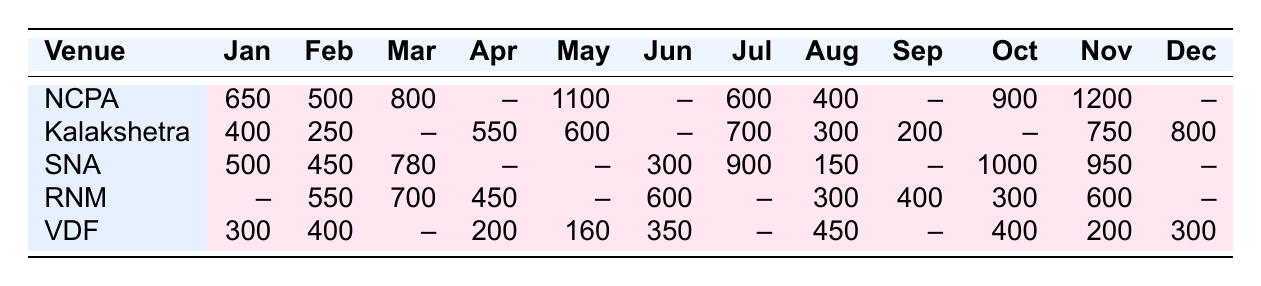What was the highest attendance recorded at the National Centre for the Performing Arts in 2023? The table shows that the highest attendance for the National Centre for the Performing Arts was in November, with a record of 1200.
Answer: 1200 Which month had the lowest attendance at the Kalakshetra Foundation? Referring to the attendance records, the lowest attendance at the Kalakshetra Foundation was in February, with 250.
Answer: 250 What is the total attendance at the Sangeet Natak Akademi for the months where records are available? By adding the recorded attendance: 500 (Jan) + 450 (Feb) + 780 (Mar) + 300 (Jun) + 900 (Jul) + 150 (Aug) + 1000 (Oct) + 950 (Nov) = 4230.
Answer: 4230 Did the Vijaywada Dance Festival show an increase in attendance from April to August? The attendance in April was 200, and in August it was 450. Since 450 is greater than 200, there was an increase in attendance from April to August.
Answer: Yes What was the average monthly attendance at the Ravindra Natya Mandir based on the available data? The recorded attendances are 550 (Feb), 700 (Mar), 450 (Apr), 600 (Jun), 300 (Aug), 400 (Sep), 300 (Oct), 600 (Nov). The total is 3000 and there are 8 months with data, giving an average of 3000/8 = 375.
Answer: 375 Which venue had a capacity closest to the average attendance recorded in the first half of 2023 across all venues? The average attendance in the first half is (650 + 500 + 400 + 250 + 500 + 450 + 300) = 3250, divided by 7 gives an average of approximately 464. The venue with a capacity close to this average is the Kalakshetra Foundation with 800.
Answer: Kalakshetra Foundation Was there any month in 2023 where all venues reported attendance? By reviewing each month, it’s clear that there were multiple months with missing data. Specifically, no month has attendance records across all five venues.
Answer: No What was the difference between the maximum and minimum attendance at the Vijaywada Dance Festival during the year? The maximum attendance was 450 in August, and the minimum was 160 in May. The difference is 450 - 160 = 290.
Answer: 290 How many months did the Sangeet Natak Akademi have canceled shows? Looking at the records, the months without attendance are April and May, totaling to 2 months with canceled shows.
Answer: 2 Which venue had the highest total attendance recorded throughout the year? By calculating total attendances, NCPA had 650 + 500 + 800 + 1100 + 600 + 400 + 900 + 1200 = 5200, which is higher than other venues.
Answer: National Centre for the Performing Arts 